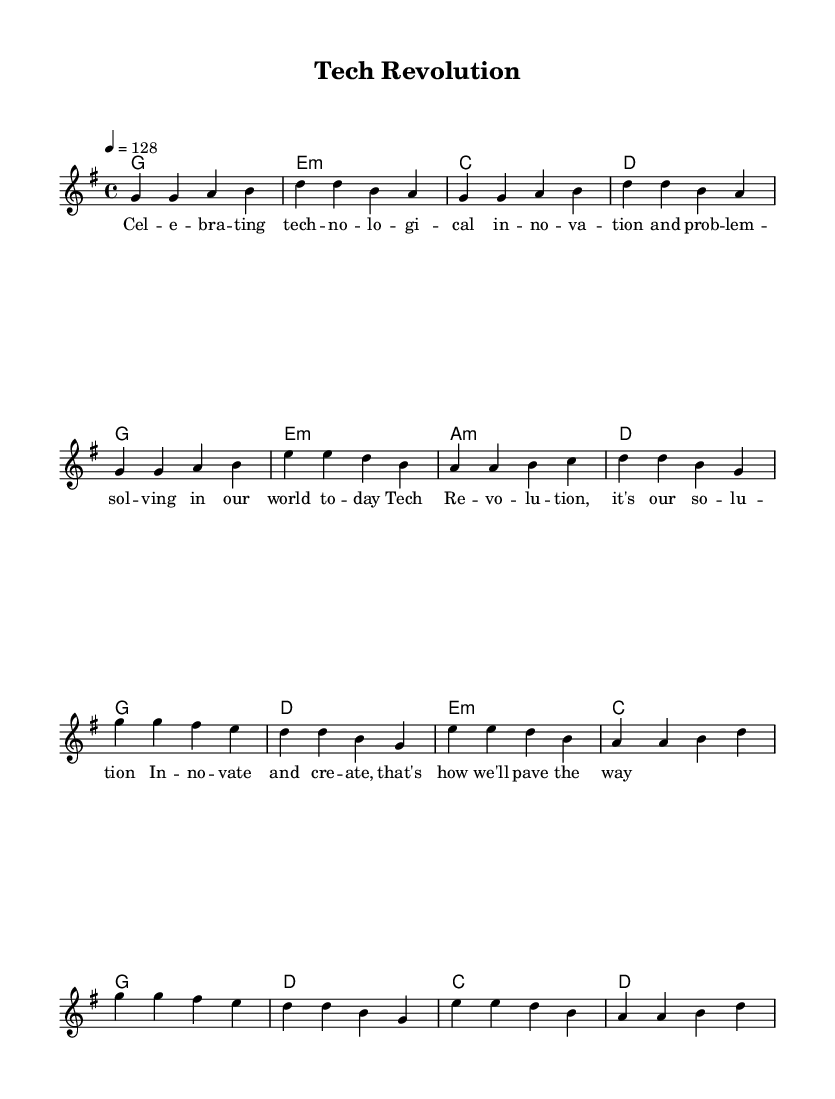What is the key signature of this music? The key signature is G major, which has one sharp (F#). This can be determined by looking at the key signature indicated at the beginning of the score, which shows a single sharp.
Answer: G major What is the time signature of this music? The time signature is 4/4, which means there are four beats per measure and the quarter note gets one beat. This is shown at the beginning of the staff notation, indicating how the beats are organized.
Answer: 4/4 What is the tempo marking for this piece? The tempo marking is 128 beats per minute, as indicated by the tempo indication at the beginning of the score. This determines how fast the piece should be played.
Answer: 128 How many measures are in the verse section? The verse section contains 8 measures. By counting the groups of bar lines in the melody section, we can see there are 8 distinct measures for the verse.
Answer: 8 What musical techniques are celebrated in the lyrics? The lyrics celebrate "technological innovation and problem-solving." This can be inferred by reading the lyrics provided along with the melody that specifically mention these techniques.
Answer: technological innovation and problem-solving What is the final chord in the chorus? The final chord in the chorus is D major, as indicated by the chord symbols listed above the melody notes towards the end of the score. This chord completes the progression for the chorus.
Answer: D What theme is present in this K-Pop piece? The theme present in this piece is about innovation and creativity in technology. This is derived from the lyrics and the overall expressions conveyed in the song celebrating progress and solutions in the modern world.
Answer: innovation and creativity in technology 